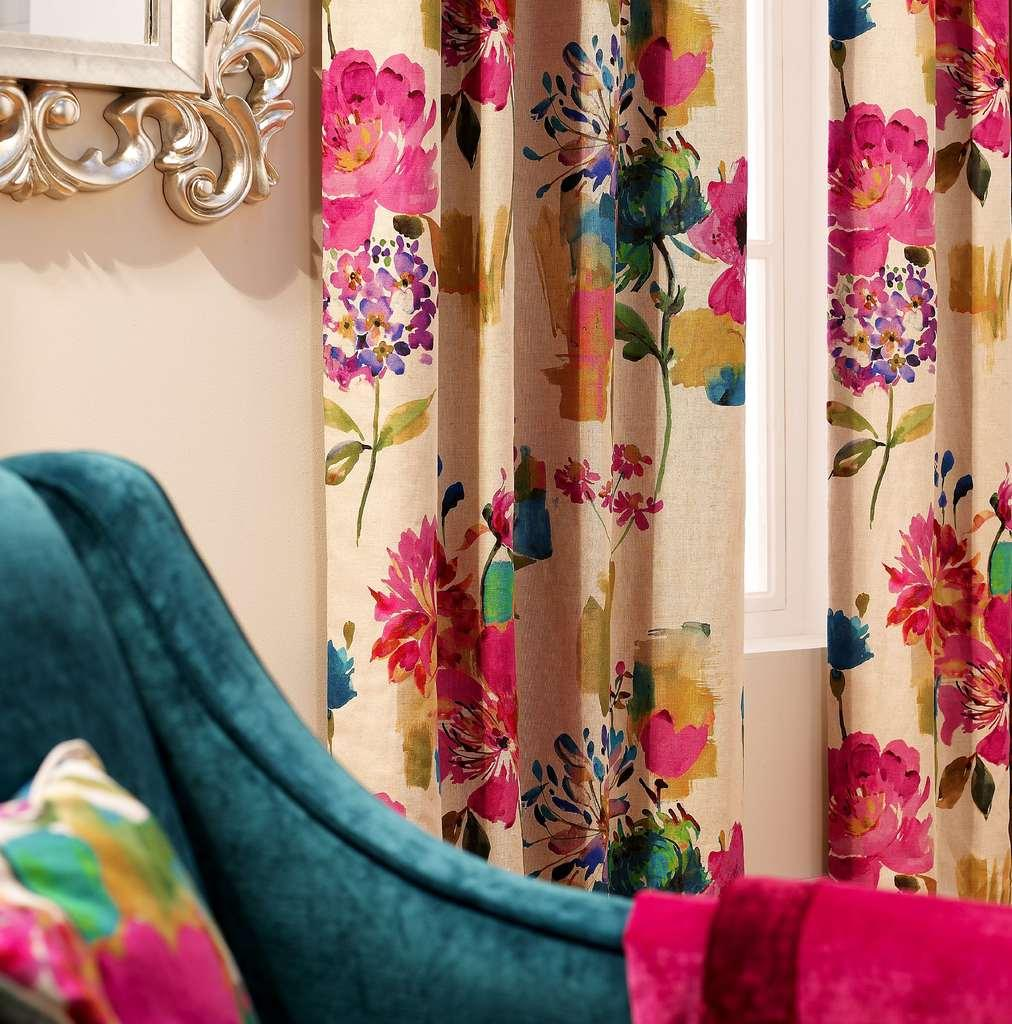What type of furniture is present in the image? There is a sofa in the image. What is placed on the sofa? There is an object on the sofa. What can be seen in the background of the image? There is a wall and a window in the background of the image. What type of window treatment is present in the image? There are curtains associated with the window. What type of current is flowing through the vessel in the image? There is no vessel or current present in the image. What knowledge can be gained from the image? The image provides information about the presence of a sofa, an object on the sofa, a wall, a window, and curtains. However, it does not convey any specific knowledge beyond these visual details. 